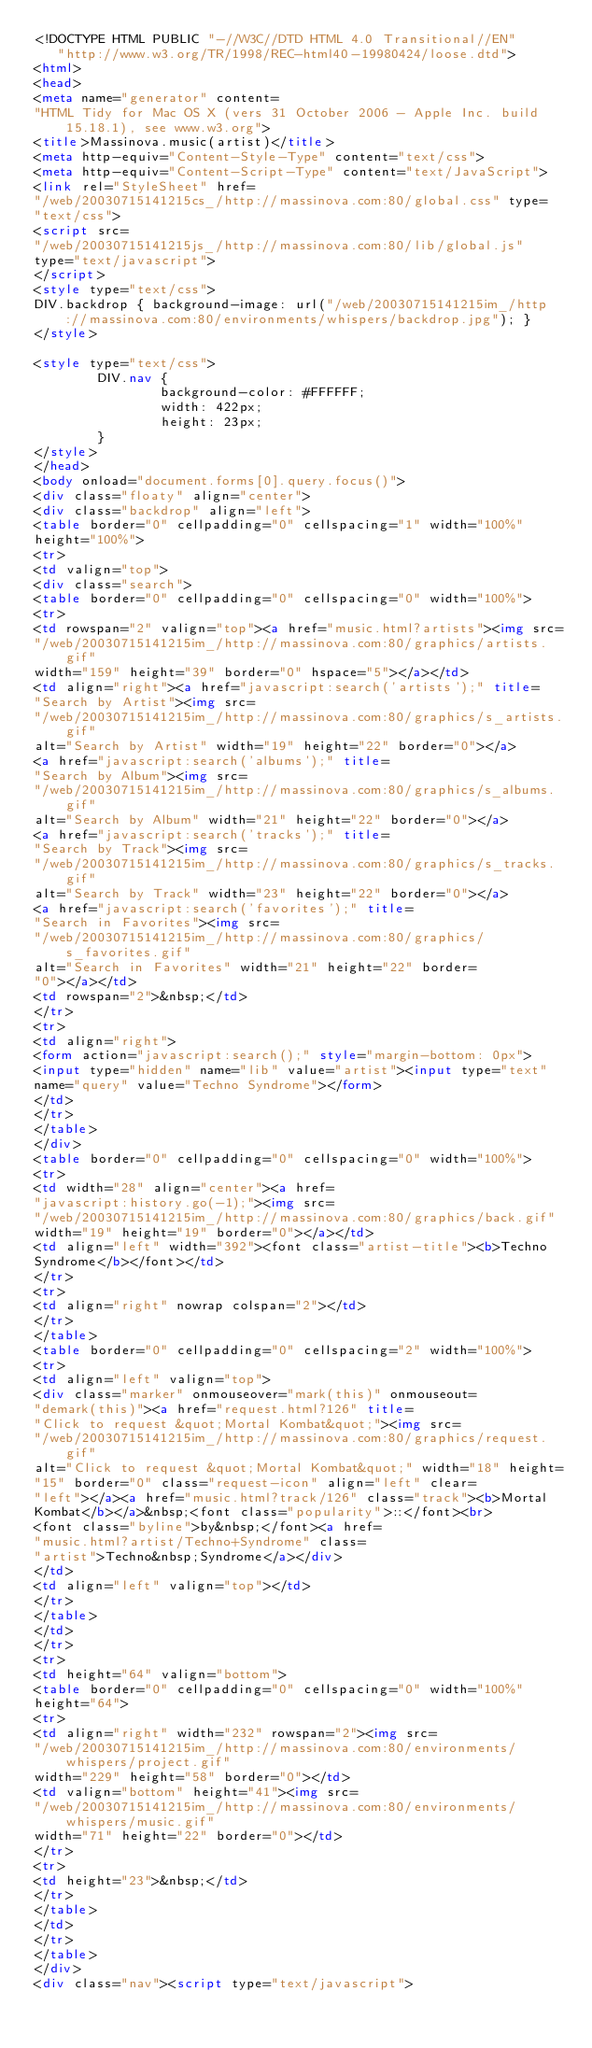<code> <loc_0><loc_0><loc_500><loc_500><_HTML_><!DOCTYPE HTML PUBLIC "-//W3C//DTD HTML 4.0 Transitional//EN"
   "http://www.w3.org/TR/1998/REC-html40-19980424/loose.dtd">
<html>
<head>
<meta name="generator" content=
"HTML Tidy for Mac OS X (vers 31 October 2006 - Apple Inc. build 15.18.1), see www.w3.org">
<title>Massinova.music(artist)</title>
<meta http-equiv="Content-Style-Type" content="text/css">
<meta http-equiv="Content-Script-Type" content="text/JavaScript">
<link rel="StyleSheet" href=
"/web/20030715141215cs_/http://massinova.com:80/global.css" type=
"text/css">
<script src=
"/web/20030715141215js_/http://massinova.com:80/lib/global.js"
type="text/javascript">
</script>
<style type="text/css">
DIV.backdrop { background-image: url("/web/20030715141215im_/http://massinova.com:80/environments/whispers/backdrop.jpg"); }
</style>

<style type="text/css">
        DIV.nav {
                background-color: #FFFFFF; 
                width: 422px;
                height: 23px;
        }
</style>
</head>
<body onload="document.forms[0].query.focus()">
<div class="floaty" align="center">
<div class="backdrop" align="left">
<table border="0" cellpadding="0" cellspacing="1" width="100%"
height="100%">
<tr>
<td valign="top">
<div class="search">
<table border="0" cellpadding="0" cellspacing="0" width="100%">
<tr>
<td rowspan="2" valign="top"><a href="music.html?artists"><img src=
"/web/20030715141215im_/http://massinova.com:80/graphics/artists.gif"
width="159" height="39" border="0" hspace="5"></a></td>
<td align="right"><a href="javascript:search('artists');" title=
"Search by Artist"><img src=
"/web/20030715141215im_/http://massinova.com:80/graphics/s_artists.gif"
alt="Search by Artist" width="19" height="22" border="0"></a>
<a href="javascript:search('albums');" title=
"Search by Album"><img src=
"/web/20030715141215im_/http://massinova.com:80/graphics/s_albums.gif"
alt="Search by Album" width="21" height="22" border="0"></a>
<a href="javascript:search('tracks');" title=
"Search by Track"><img src=
"/web/20030715141215im_/http://massinova.com:80/graphics/s_tracks.gif"
alt="Search by Track" width="23" height="22" border="0"></a>
<a href="javascript:search('favorites');" title=
"Search in Favorites"><img src=
"/web/20030715141215im_/http://massinova.com:80/graphics/s_favorites.gif"
alt="Search in Favorites" width="21" height="22" border=
"0"></a></td>
<td rowspan="2">&nbsp;</td>
</tr>
<tr>
<td align="right">
<form action="javascript:search();" style="margin-bottom: 0px">
<input type="hidden" name="lib" value="artist"><input type="text"
name="query" value="Techno Syndrome"></form>
</td>
</tr>
</table>
</div>
<table border="0" cellpadding="0" cellspacing="0" width="100%">
<tr>
<td width="28" align="center"><a href=
"javascript:history.go(-1);"><img src=
"/web/20030715141215im_/http://massinova.com:80/graphics/back.gif"
width="19" height="19" border="0"></a></td>
<td align="left" width="392"><font class="artist-title"><b>Techno
Syndrome</b></font></td>
</tr>
<tr>
<td align="right" nowrap colspan="2"></td>
</tr>
</table>
<table border="0" cellpadding="0" cellspacing="2" width="100%">
<tr>
<td align="left" valign="top">
<div class="marker" onmouseover="mark(this)" onmouseout=
"demark(this)"><a href="request.html?126" title=
"Click to request &quot;Mortal Kombat&quot;"><img src=
"/web/20030715141215im_/http://massinova.com:80/graphics/request.gif"
alt="Click to request &quot;Mortal Kombat&quot;" width="18" height=
"15" border="0" class="request-icon" align="left" clear=
"left"></a><a href="music.html?track/126" class="track"><b>Mortal
Kombat</b></a>&nbsp;<font class="popularity">::</font><br>
<font class="byline">by&nbsp;</font><a href=
"music.html?artist/Techno+Syndrome" class=
"artist">Techno&nbsp;Syndrome</a></div>
</td>
<td align="left" valign="top"></td>
</tr>
</table>
</td>
</tr>
<tr>
<td height="64" valign="bottom">
<table border="0" cellpadding="0" cellspacing="0" width="100%"
height="64">
<tr>
<td align="right" width="232" rowspan="2"><img src=
"/web/20030715141215im_/http://massinova.com:80/environments/whispers/project.gif"
width="229" height="58" border="0"></td>
<td valign="bottom" height="41"><img src=
"/web/20030715141215im_/http://massinova.com:80/environments/whispers/music.gif"
width="71" height="22" border="0"></td>
</tr>
<tr>
<td height="23">&nbsp;</td>
</tr>
</table>
</td>
</tr>
</table>
</div>
<div class="nav"><script type="text/javascript"></code> 